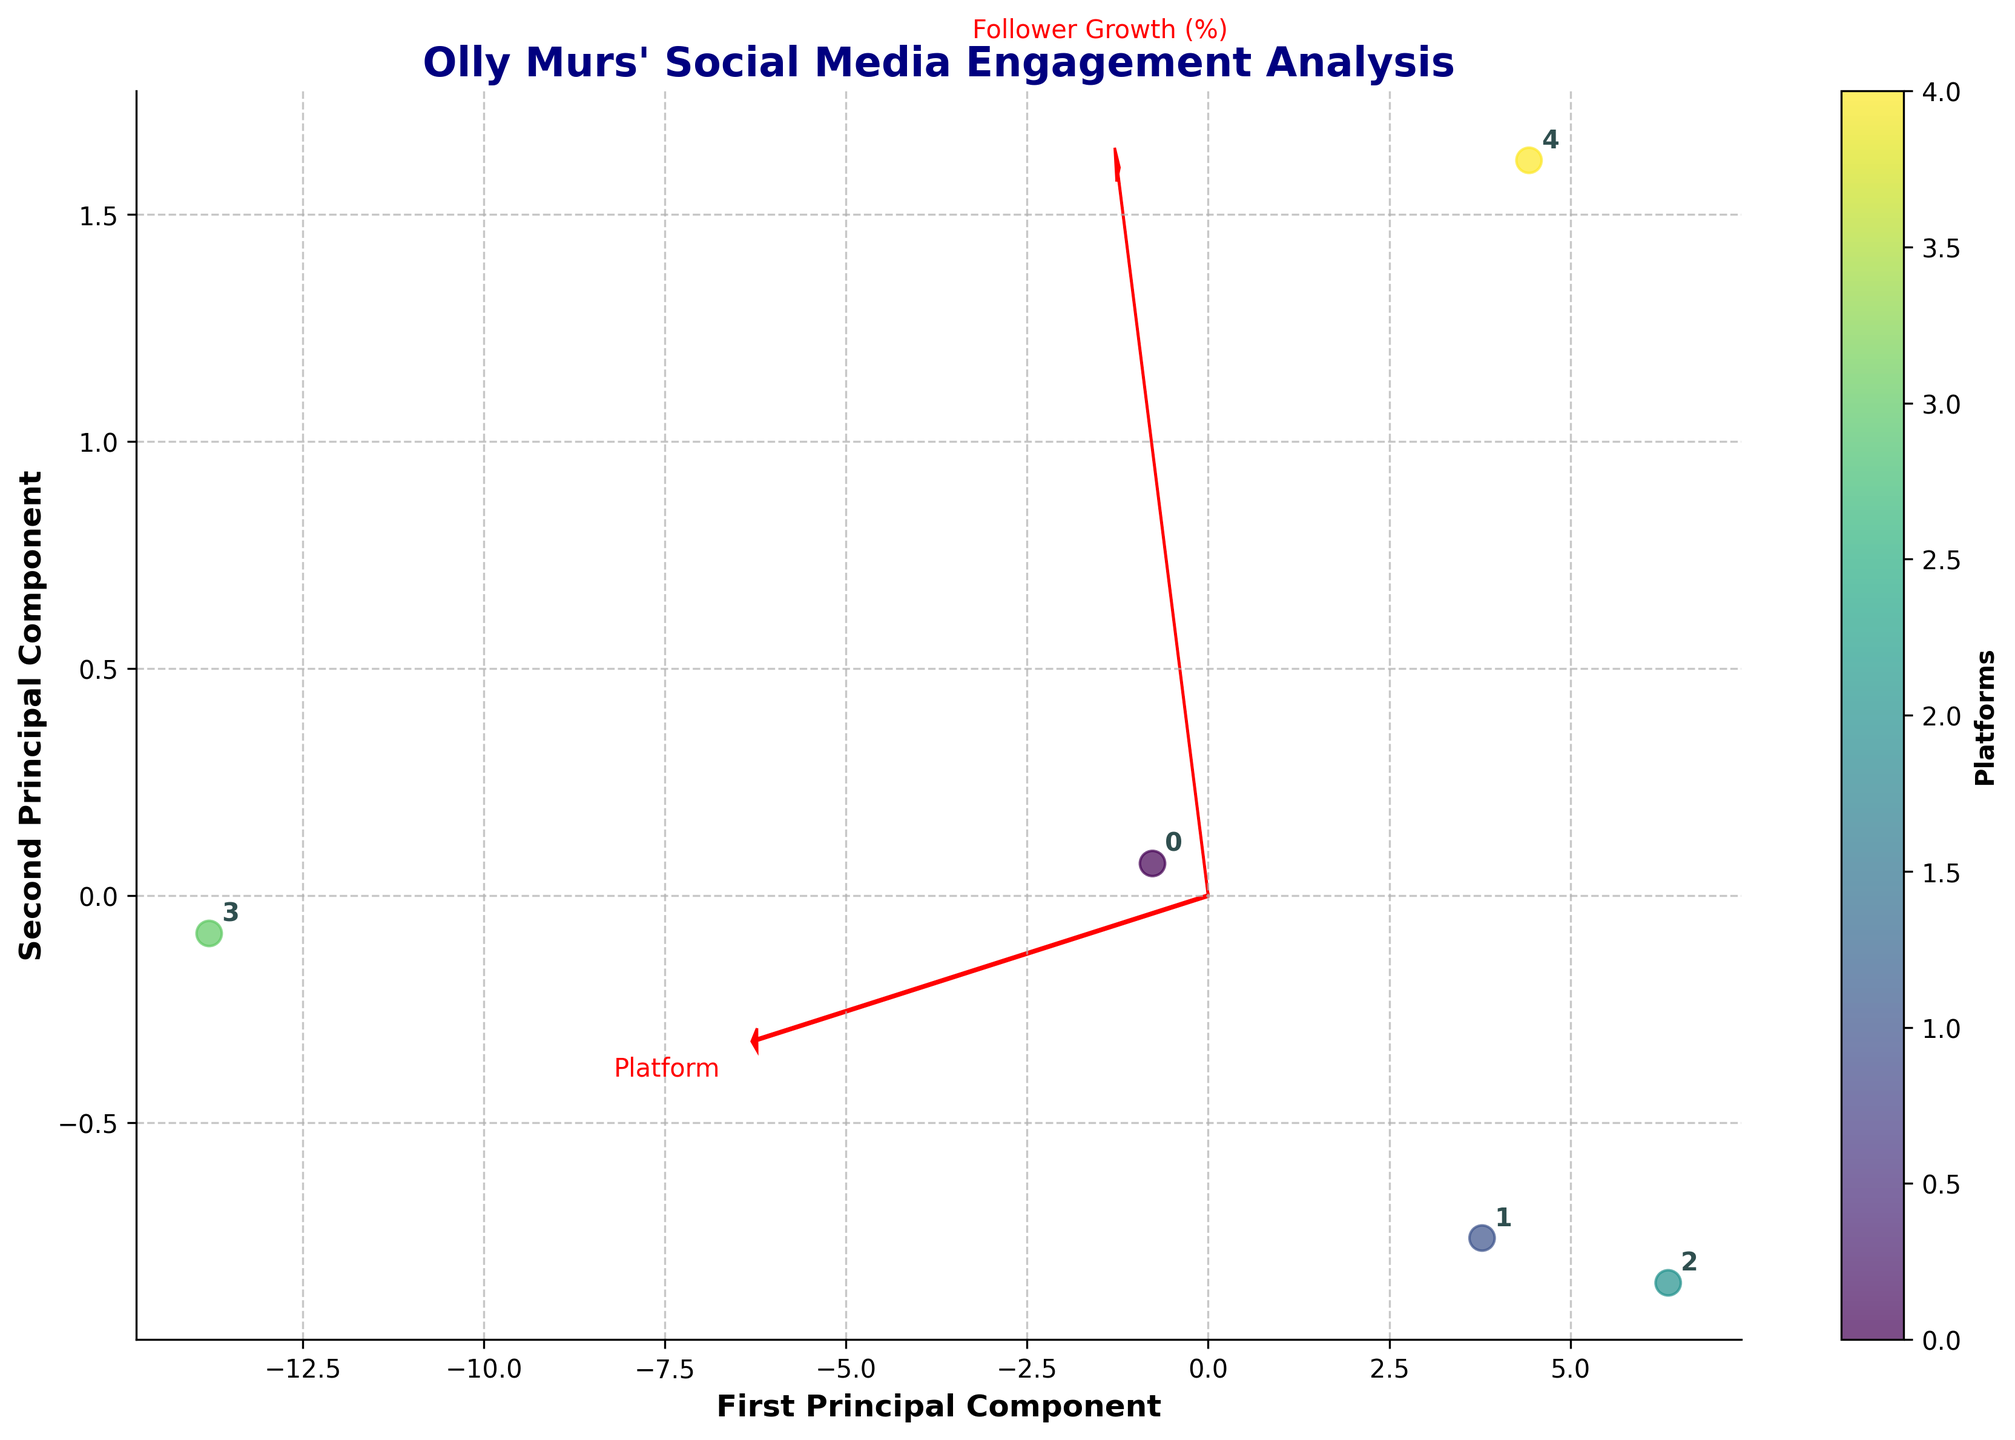how many platforms are analyzed in the figure? The figure plots data points for each platform analyzed. By counting the labels or data points, we can determine the total number of platforms included in the analysis.
Answer: 6 what are the two principal components labeled on the axes? The axes labels in the Biplot indicate the two principal components which are usually used to reduce the dimensionality of the data. The x-axis is labeled as 'First Principal Component' and the y-axis is labeled as 'Second Principal Component'.
Answer: First Principal Component, Second Principal Component which platform has the highest engagement rate and how is it visually represented in the Biplot? To find the platform with the highest engagement rate, we should look for the data point located furthest along the direction of the engagement rate vector (red arrow) in the Biplot. This platform would be at a position nearest in alignment with the red arrow representing engagement rate.
Answer: TikTok which two platforms are closest together in terms of the first and second principal components? By visually inspecting the relative positions of the data points in the Biplot, we can determine which two platforms are closest to each other. This involves noting which two points appear nearest to each other in the 2D spatial projection.
Answer: Instagram and Twitter how does the engagement rate vector compare directionally with the follower growth vector in the Biplot? By looking at the red arrows in the Biplot, we can compare the directional paths of the engagement rate vector and the follower growth vector. The vectors' relative orientation (i.e., if they are pointing similarly, oppositely, or orthogonally) will help answer this.
Answer: Somewhat aligned but slightly deviating how does Facebook compare to YouTube in terms of their positions on the first two principal components? We'll locate Facebook and YouTube on the Biplot and compare their positions relative to the axes representing the two principal components. Analyze their spatial alignment to assess differences.
Answer: Facebook is positioned left and lower; YouTube right and higher which platform exhibits the greatest variance along the second principal component? We identify the platform with the highest absolute value in the vertical direction, representing the second principal component in the Biplot. This platform will be farthest from the horizontal axis.
Answer: TikTok what does the colorbar in the figure represent, and how can it be used to interpret the data points? The colorbar next to the scatter plot helps differentiate the platforms visually by assigning distinct colors to each platform. This allows tracking which platform corresponds to which data points based on their color.
Answer: Platforms which platform has the lowest interaction metric by checking its proximity to the origin? The interaction metric may refer indirectly to engagement or follower growth. Checking the data point nearest the origin (0,0) can help identify the platform with the lowest activity. This point will appear nearest to the center of the Biplot's coordinate axes.
Answer: Facebook 